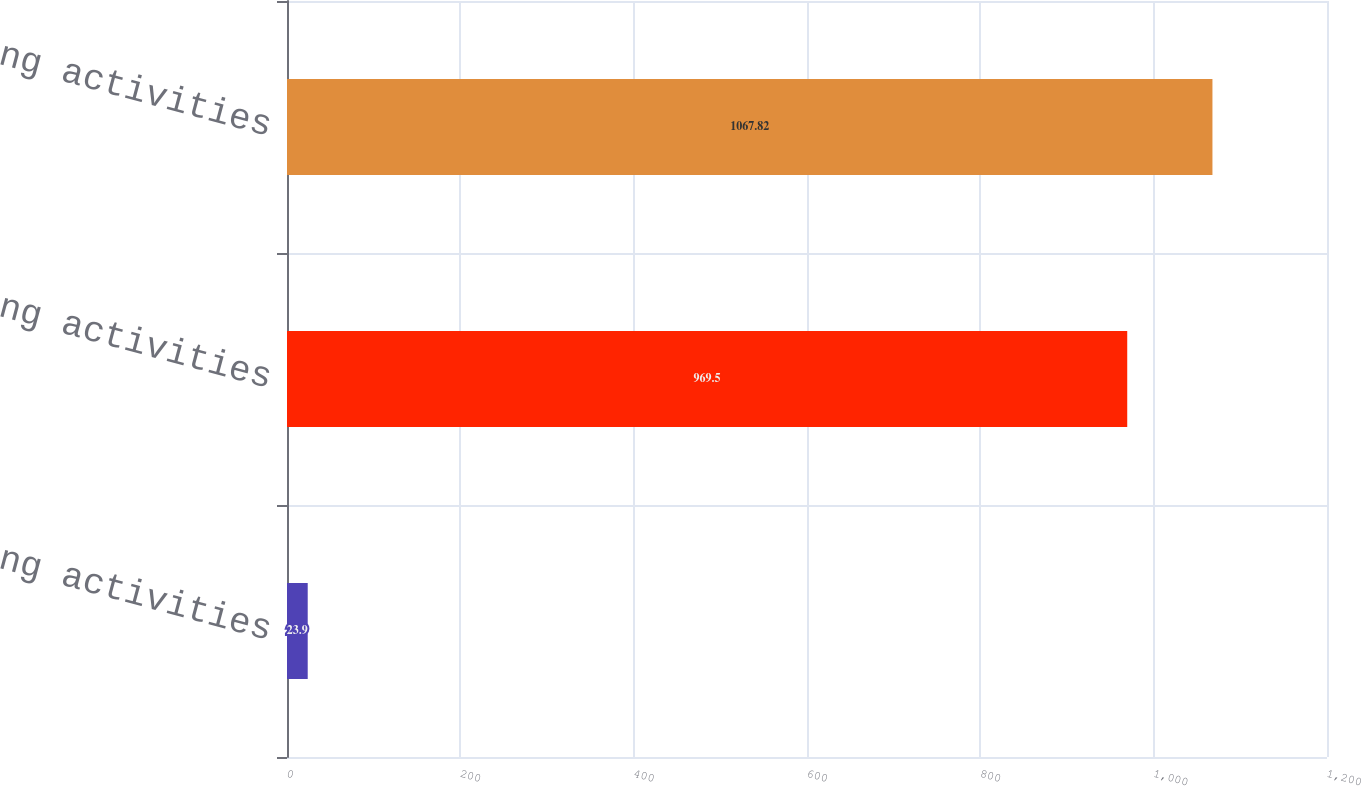<chart> <loc_0><loc_0><loc_500><loc_500><bar_chart><fcel>Operating activities<fcel>Investing activities<fcel>Financing activities<nl><fcel>23.9<fcel>969.5<fcel>1067.82<nl></chart> 